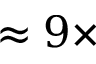Convert formula to latex. <formula><loc_0><loc_0><loc_500><loc_500>\approx 9 \times</formula> 